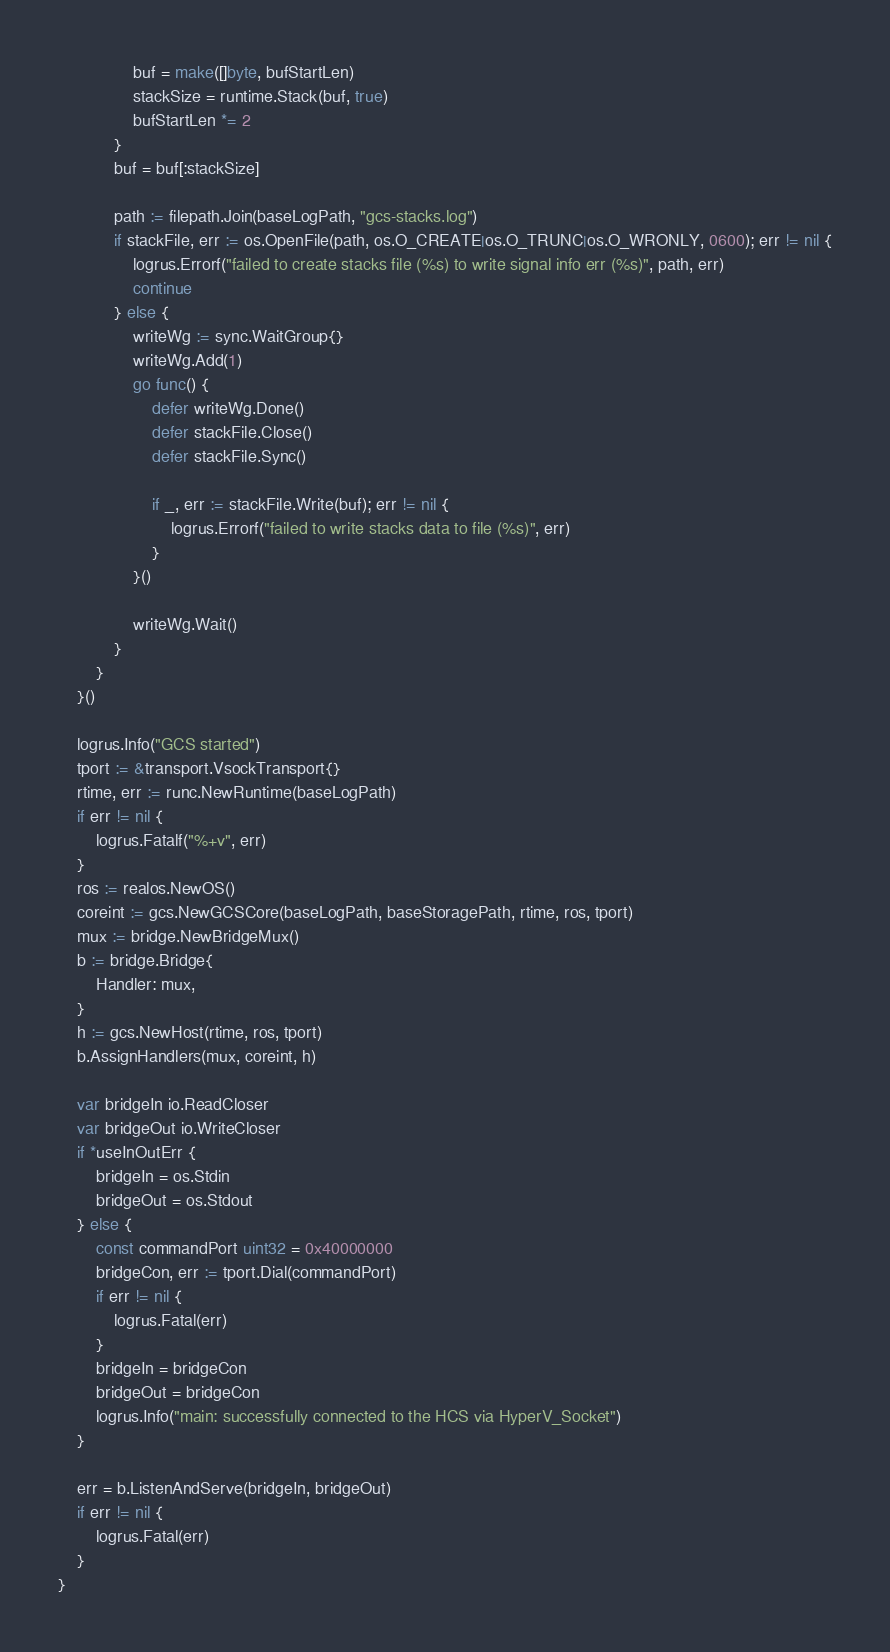<code> <loc_0><loc_0><loc_500><loc_500><_Go_>				buf = make([]byte, bufStartLen)
				stackSize = runtime.Stack(buf, true)
				bufStartLen *= 2
			}
			buf = buf[:stackSize]

			path := filepath.Join(baseLogPath, "gcs-stacks.log")
			if stackFile, err := os.OpenFile(path, os.O_CREATE|os.O_TRUNC|os.O_WRONLY, 0600); err != nil {
				logrus.Errorf("failed to create stacks file (%s) to write signal info err (%s)", path, err)
				continue
			} else {
				writeWg := sync.WaitGroup{}
				writeWg.Add(1)
				go func() {
					defer writeWg.Done()
					defer stackFile.Close()
					defer stackFile.Sync()

					if _, err := stackFile.Write(buf); err != nil {
						logrus.Errorf("failed to write stacks data to file (%s)", err)
					}
				}()

				writeWg.Wait()
			}
		}
	}()

	logrus.Info("GCS started")
	tport := &transport.VsockTransport{}
	rtime, err := runc.NewRuntime(baseLogPath)
	if err != nil {
		logrus.Fatalf("%+v", err)
	}
	ros := realos.NewOS()
	coreint := gcs.NewGCSCore(baseLogPath, baseStoragePath, rtime, ros, tport)
	mux := bridge.NewBridgeMux()
	b := bridge.Bridge{
		Handler: mux,
	}
	h := gcs.NewHost(rtime, ros, tport)
	b.AssignHandlers(mux, coreint, h)

	var bridgeIn io.ReadCloser
	var bridgeOut io.WriteCloser
	if *useInOutErr {
		bridgeIn = os.Stdin
		bridgeOut = os.Stdout
	} else {
		const commandPort uint32 = 0x40000000
		bridgeCon, err := tport.Dial(commandPort)
		if err != nil {
			logrus.Fatal(err)
		}
		bridgeIn = bridgeCon
		bridgeOut = bridgeCon
		logrus.Info("main: successfully connected to the HCS via HyperV_Socket")
	}

	err = b.ListenAndServe(bridgeIn, bridgeOut)
	if err != nil {
		logrus.Fatal(err)
	}
}
</code> 